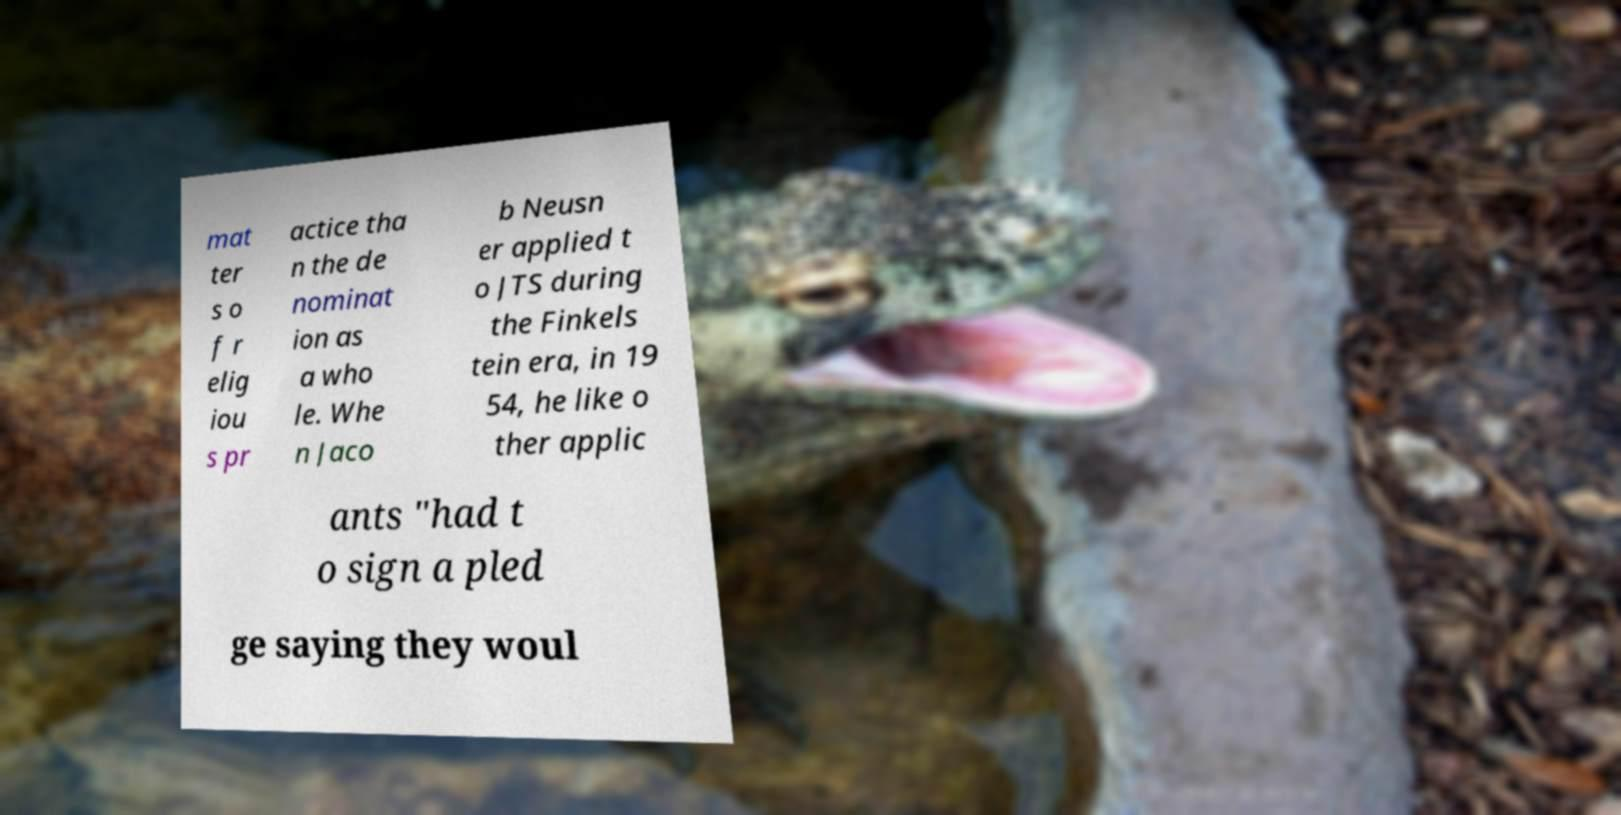There's text embedded in this image that I need extracted. Can you transcribe it verbatim? mat ter s o f r elig iou s pr actice tha n the de nominat ion as a who le. Whe n Jaco b Neusn er applied t o JTS during the Finkels tein era, in 19 54, he like o ther applic ants "had t o sign a pled ge saying they woul 